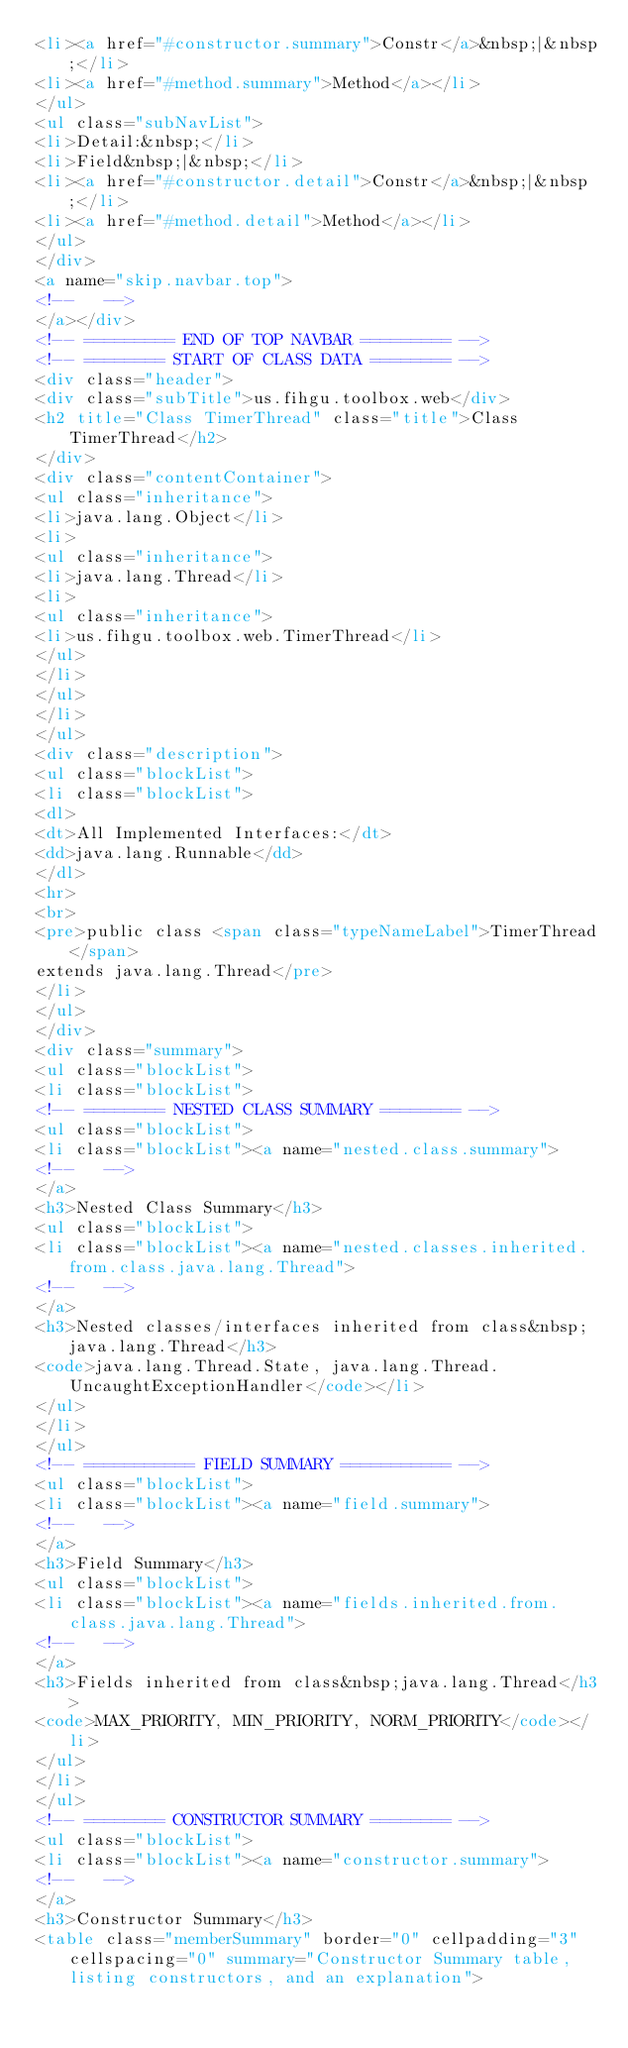<code> <loc_0><loc_0><loc_500><loc_500><_HTML_><li><a href="#constructor.summary">Constr</a>&nbsp;|&nbsp;</li>
<li><a href="#method.summary">Method</a></li>
</ul>
<ul class="subNavList">
<li>Detail:&nbsp;</li>
<li>Field&nbsp;|&nbsp;</li>
<li><a href="#constructor.detail">Constr</a>&nbsp;|&nbsp;</li>
<li><a href="#method.detail">Method</a></li>
</ul>
</div>
<a name="skip.navbar.top">
<!--   -->
</a></div>
<!-- ========= END OF TOP NAVBAR ========= -->
<!-- ======== START OF CLASS DATA ======== -->
<div class="header">
<div class="subTitle">us.fihgu.toolbox.web</div>
<h2 title="Class TimerThread" class="title">Class TimerThread</h2>
</div>
<div class="contentContainer">
<ul class="inheritance">
<li>java.lang.Object</li>
<li>
<ul class="inheritance">
<li>java.lang.Thread</li>
<li>
<ul class="inheritance">
<li>us.fihgu.toolbox.web.TimerThread</li>
</ul>
</li>
</ul>
</li>
</ul>
<div class="description">
<ul class="blockList">
<li class="blockList">
<dl>
<dt>All Implemented Interfaces:</dt>
<dd>java.lang.Runnable</dd>
</dl>
<hr>
<br>
<pre>public class <span class="typeNameLabel">TimerThread</span>
extends java.lang.Thread</pre>
</li>
</ul>
</div>
<div class="summary">
<ul class="blockList">
<li class="blockList">
<!-- ======== NESTED CLASS SUMMARY ======== -->
<ul class="blockList">
<li class="blockList"><a name="nested.class.summary">
<!--   -->
</a>
<h3>Nested Class Summary</h3>
<ul class="blockList">
<li class="blockList"><a name="nested.classes.inherited.from.class.java.lang.Thread">
<!--   -->
</a>
<h3>Nested classes/interfaces inherited from class&nbsp;java.lang.Thread</h3>
<code>java.lang.Thread.State, java.lang.Thread.UncaughtExceptionHandler</code></li>
</ul>
</li>
</ul>
<!-- =========== FIELD SUMMARY =========== -->
<ul class="blockList">
<li class="blockList"><a name="field.summary">
<!--   -->
</a>
<h3>Field Summary</h3>
<ul class="blockList">
<li class="blockList"><a name="fields.inherited.from.class.java.lang.Thread">
<!--   -->
</a>
<h3>Fields inherited from class&nbsp;java.lang.Thread</h3>
<code>MAX_PRIORITY, MIN_PRIORITY, NORM_PRIORITY</code></li>
</ul>
</li>
</ul>
<!-- ======== CONSTRUCTOR SUMMARY ======== -->
<ul class="blockList">
<li class="blockList"><a name="constructor.summary">
<!--   -->
</a>
<h3>Constructor Summary</h3>
<table class="memberSummary" border="0" cellpadding="3" cellspacing="0" summary="Constructor Summary table, listing constructors, and an explanation"></code> 